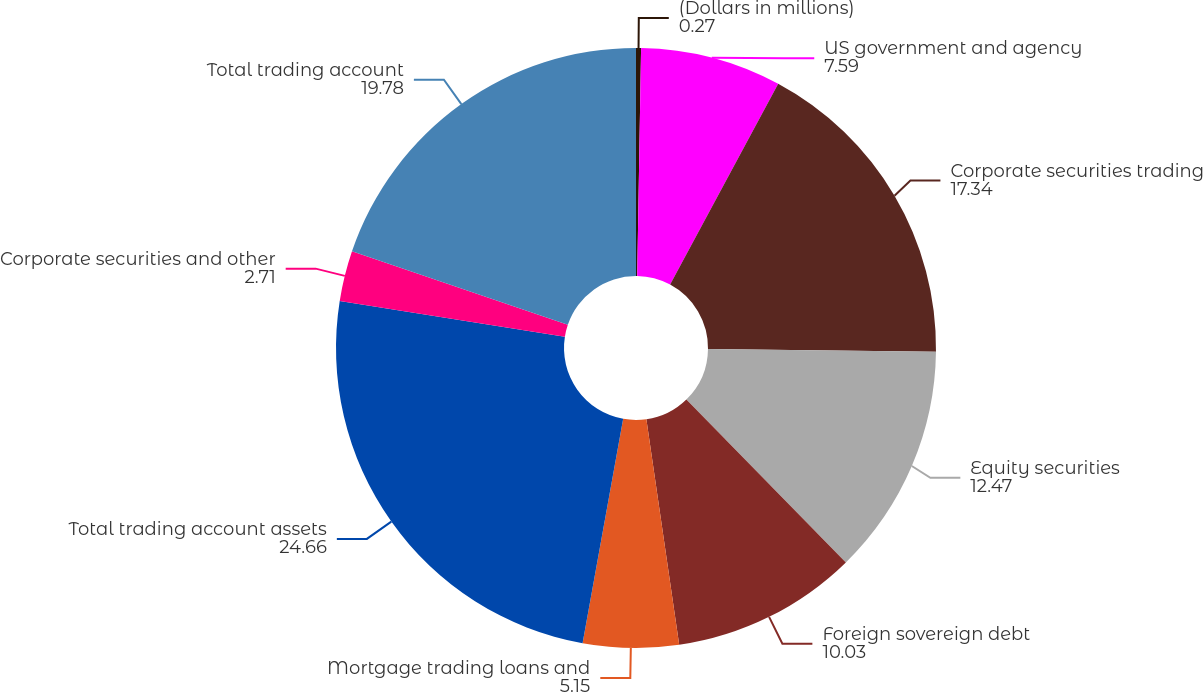Convert chart. <chart><loc_0><loc_0><loc_500><loc_500><pie_chart><fcel>(Dollars in millions)<fcel>US government and agency<fcel>Corporate securities trading<fcel>Equity securities<fcel>Foreign sovereign debt<fcel>Mortgage trading loans and<fcel>Total trading account assets<fcel>Corporate securities and other<fcel>Total trading account<nl><fcel>0.27%<fcel>7.59%<fcel>17.34%<fcel>12.47%<fcel>10.03%<fcel>5.15%<fcel>24.66%<fcel>2.71%<fcel>19.78%<nl></chart> 